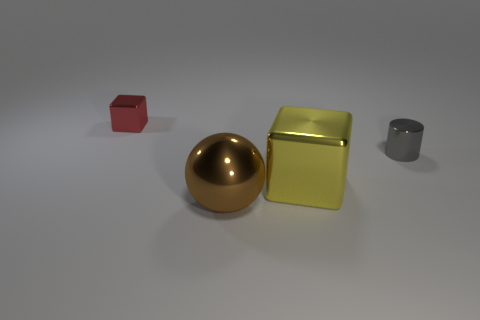There is a object that is to the right of the big metal sphere and left of the tiny gray thing; what is its shape?
Your answer should be very brief. Cube. Are there any big brown metal balls?
Your answer should be very brief. Yes. There is a small red thing that is the same shape as the large yellow thing; what is it made of?
Provide a short and direct response. Metal. The thing that is behind the small metallic thing to the right of the tiny thing behind the tiny metallic cylinder is what shape?
Keep it short and to the point. Cube. How many tiny shiny things have the same shape as the large brown metallic object?
Give a very brief answer. 0. There is a thing that is the same size as the cylinder; what material is it?
Your answer should be compact. Metal. Are there any yellow blocks that have the same size as the brown metallic thing?
Offer a very short reply. Yes. Is the number of yellow things that are behind the gray object less than the number of brown matte cylinders?
Your response must be concise. No. Are there fewer yellow shiny cubes that are left of the small red thing than metallic things that are to the left of the large yellow cube?
Your answer should be compact. Yes. How many balls are tiny cyan objects or big brown things?
Make the answer very short. 1. 